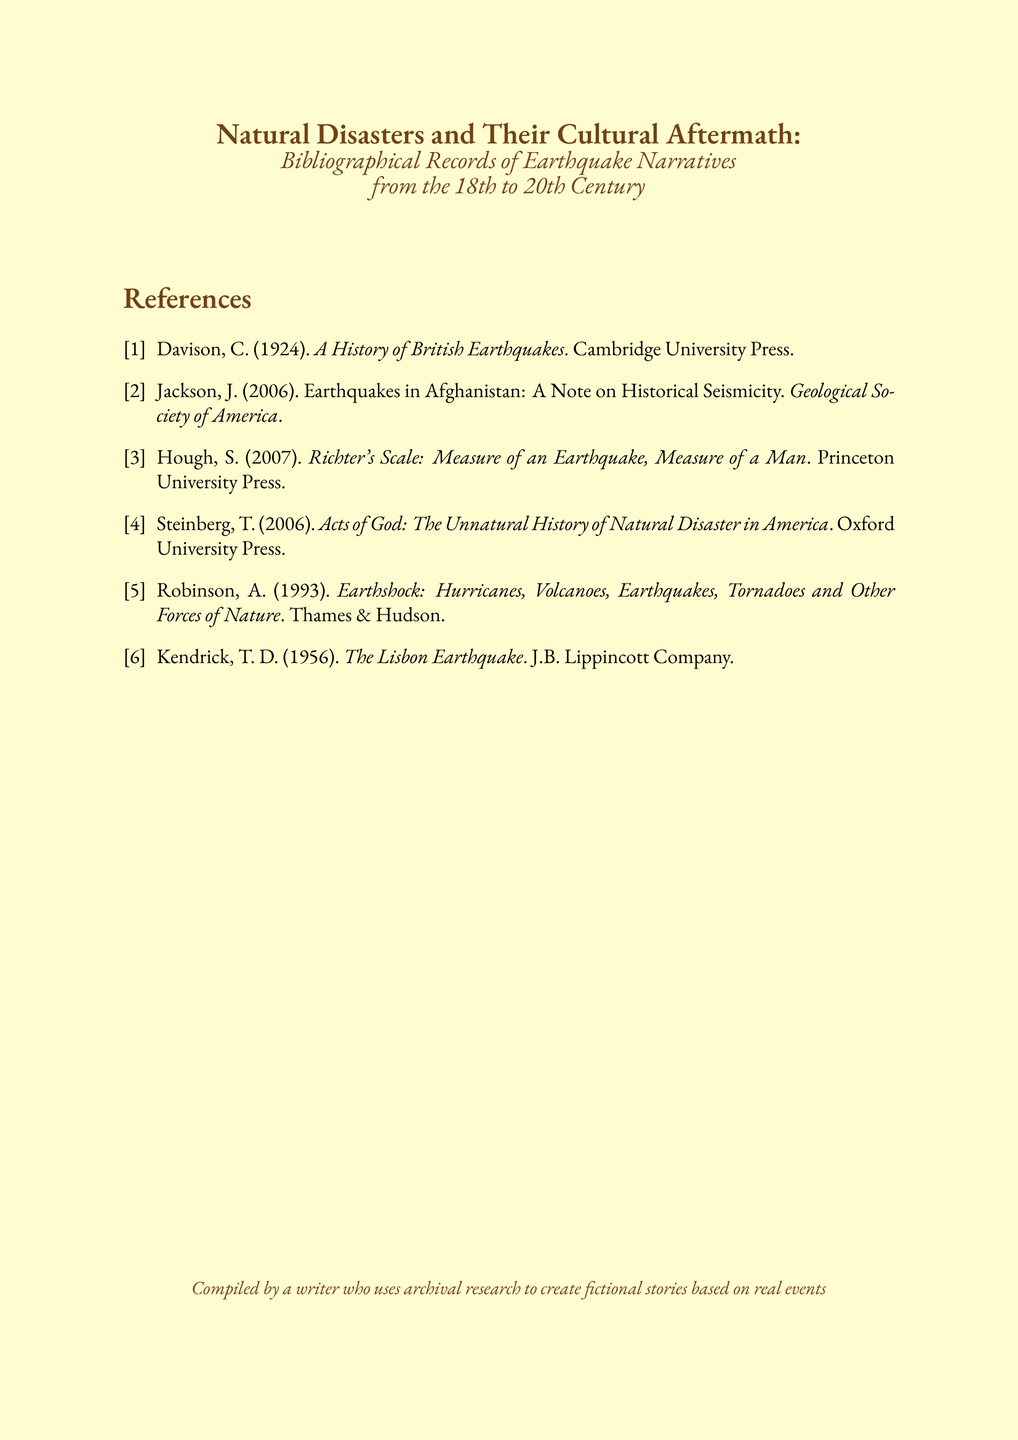What is the title of the document? The title of the document is found at the top and summarizes the overall theme regarding natural disasters and cultural aftermath.
Answer: Natural Disasters and Their Cultural Aftermath Who is the author of "A History of British Earthquakes"? This book's authorship is identified in the bibliography, which attributes it to a specific author.
Answer: C. Davison In what year was "Richter's Scale" published? The publication year of this specific book is noted in the bibliography under its respective entry.
Answer: 2007 How many sources are cited in the bibliography? The number of sources is indicated by the total number of entries in the bibliography section.
Answer: 6 What type of publication is "Acts of God"? This refers to the publication's genre as presented in the bibliography entry, indicating its nature or category.
Answer: Book Which publisher released "Earthshock"? The publisher mentioned in the bibliography for this work indicates the organization responsible for its distribution.
Answer: Thames & Hudson What event does Kendrick's book specifically address? The title of the book provides insight into the specific historical natural disaster it explores.
Answer: The Lisbon Earthquake Which author wrote about earthquakes in Afghanistan? The specific entry in the bibliography shows the author's name associated with the relevant work.
Answer: J. Jackson 